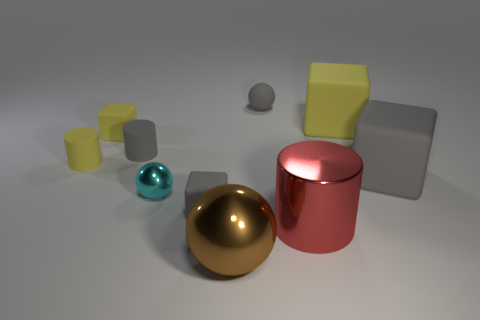There is a big thing that is the same color as the rubber sphere; what is it made of?
Your response must be concise. Rubber. Are there any small cylinders on the right side of the red thing?
Your answer should be compact. No. Are there any other large things that have the same shape as the large brown thing?
Keep it short and to the point. No. Does the large metallic thing right of the brown thing have the same shape as the gray rubber thing to the right of the large cylinder?
Make the answer very short. No. Are there any red objects of the same size as the yellow rubber cylinder?
Make the answer very short. No. Is the number of small spheres to the right of the big gray rubber block the same as the number of rubber cylinders in front of the red cylinder?
Make the answer very short. Yes. Are the yellow cube on the right side of the brown metallic sphere and the cylinder that is to the right of the matte ball made of the same material?
Provide a short and direct response. No. What is the material of the large brown ball?
Ensure brevity in your answer.  Metal. What number of other things are there of the same color as the small metal ball?
Offer a very short reply. 0. Is the color of the large cylinder the same as the rubber sphere?
Your answer should be compact. No. 